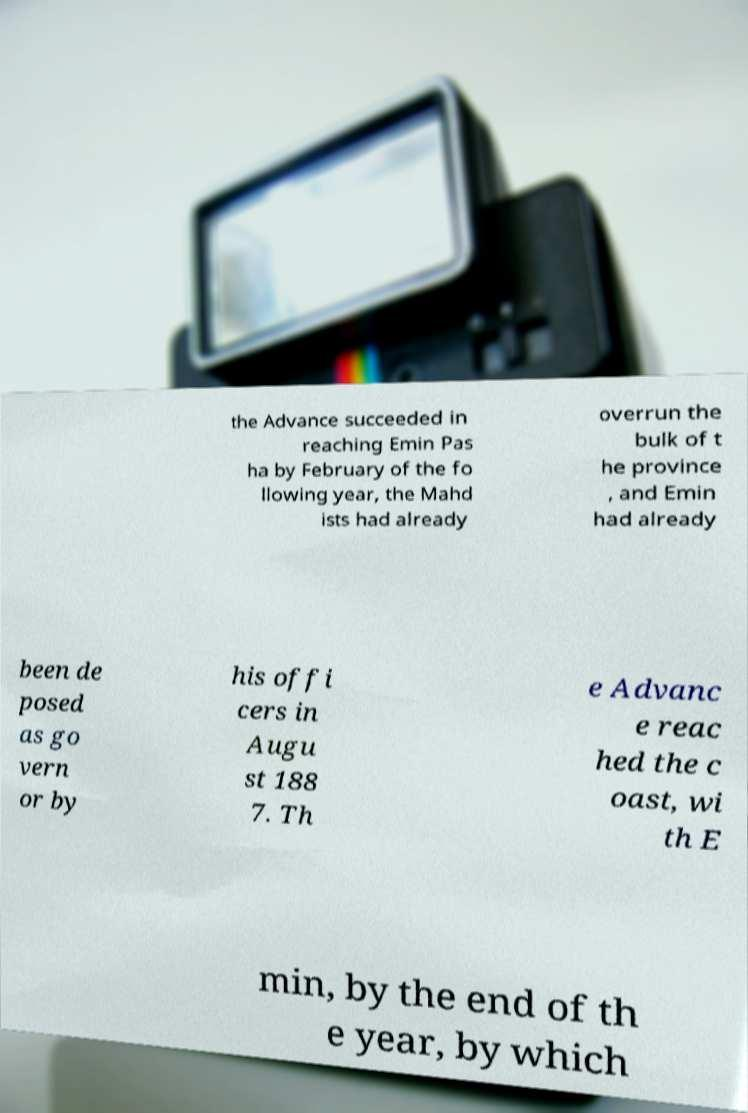Could you extract and type out the text from this image? the Advance succeeded in reaching Emin Pas ha by February of the fo llowing year, the Mahd ists had already overrun the bulk of t he province , and Emin had already been de posed as go vern or by his offi cers in Augu st 188 7. Th e Advanc e reac hed the c oast, wi th E min, by the end of th e year, by which 